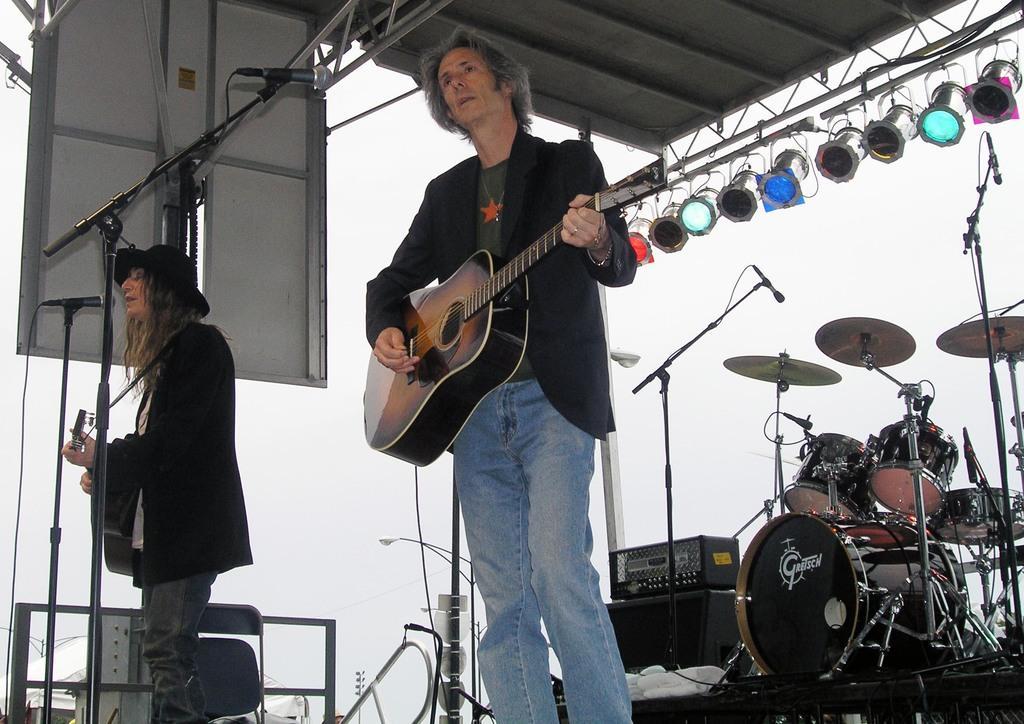Could you give a brief overview of what you see in this image? In this image I can see two men and both of them are holding guitar in their hands. Here I can see a mic and a drum set. In the background I can see number of lights. 